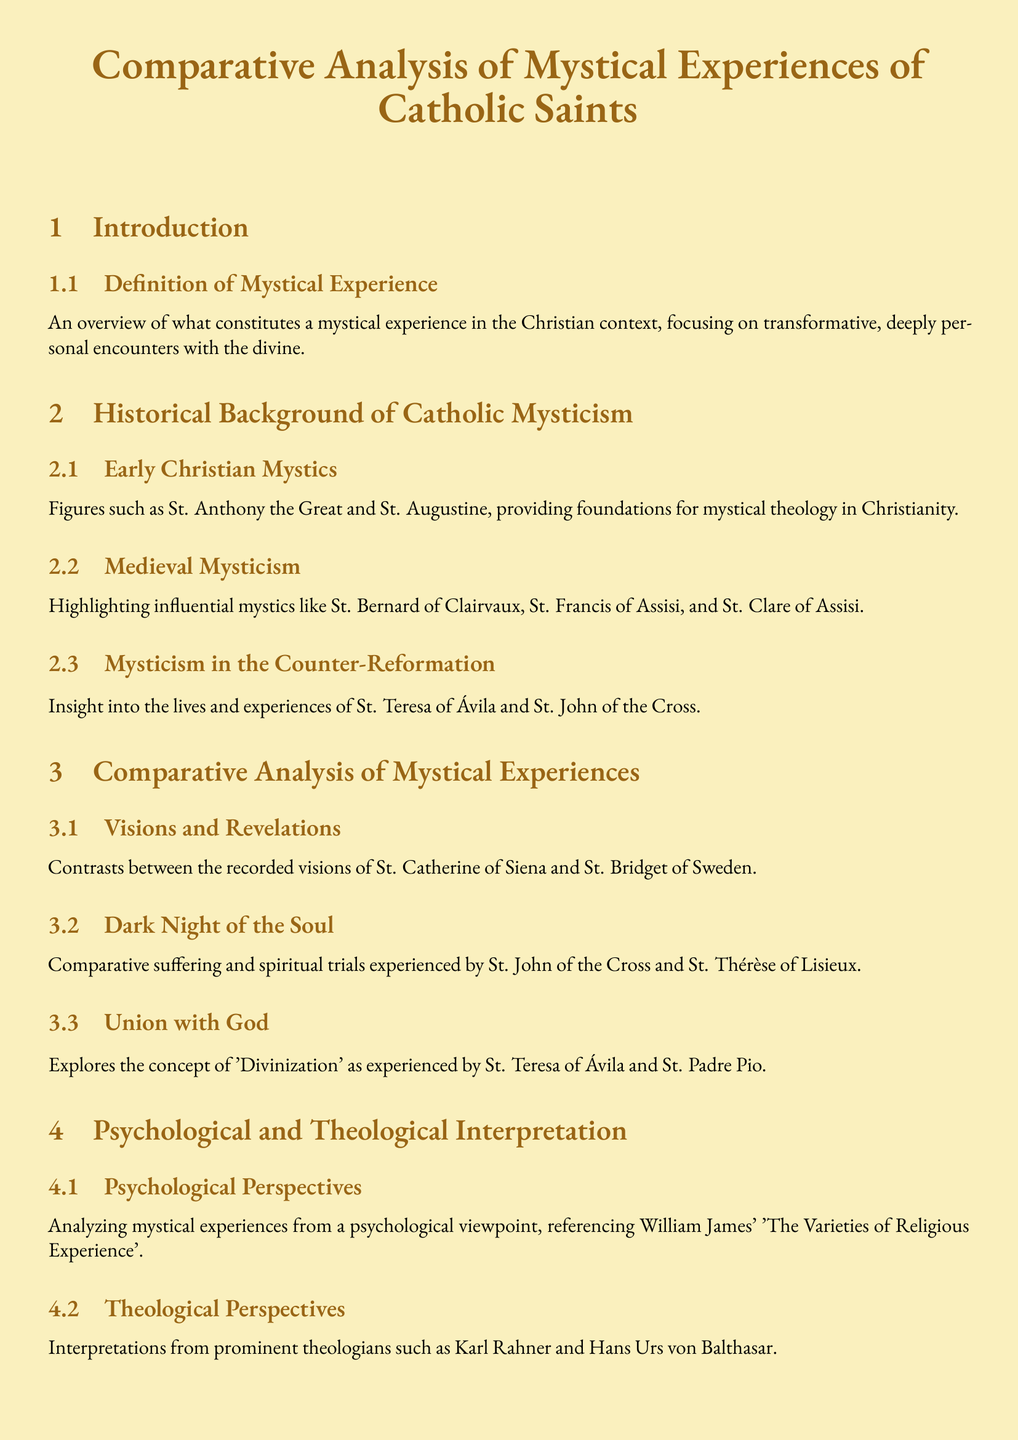what is the title of the document? The title is provided in the center of the document, clearly indicating the main topic of the analysis.
Answer: Comparative Analysis of Mystical Experiences of Catholic Saints who is highlighted as a figure in early Christian mysticism? The document lists significant figures in early Christian mysticism, one of which is mentioned in the subsection title.
Answer: St. Anthony the Great which section discusses the psychological perspective on mystical experiences? The section heading indicates the focus on psychological aspects and references prominent works in psychology.
Answer: Psychological Perspectives name one of the mystics analyzed for the "Dark Night of the Soul." This term refers specifically to the experiences related to suffering and spiritual trials, indicating a notable mystic associated with this theme.
Answer: St. John of the Cross what is the focus of the subsection titled "Union with God"? The subsection explores a central concept in Catholic mysticism, detailing the experiences mentioned in relation to two significant saints.
Answer: Divinization who wrote 'The Varieties of Religious Experience'? The document provides context on psychological perspectives that reference this specific work to analyze mystical experiences.
Answer: William James which two saints are compared in the section on "Visions and Revelations"? The document specifically mentions these two saints in relation to their recorded visions, serving as a focal point of comparison.
Answer: St. Catherine of Siena and St. Bridget of Sweden what is the implication discussed for modern Catholic devotees? The conclusion summarizes the impact of the study of mystical experiences on contemporary religious practices.
Answer: Deepen contemporary spiritual practice what medieval mystic is mentioned as part of the historical background? The section discusses influential figures in the medieval period, one of which is included in the text.
Answer: St. Francis of Assisi 